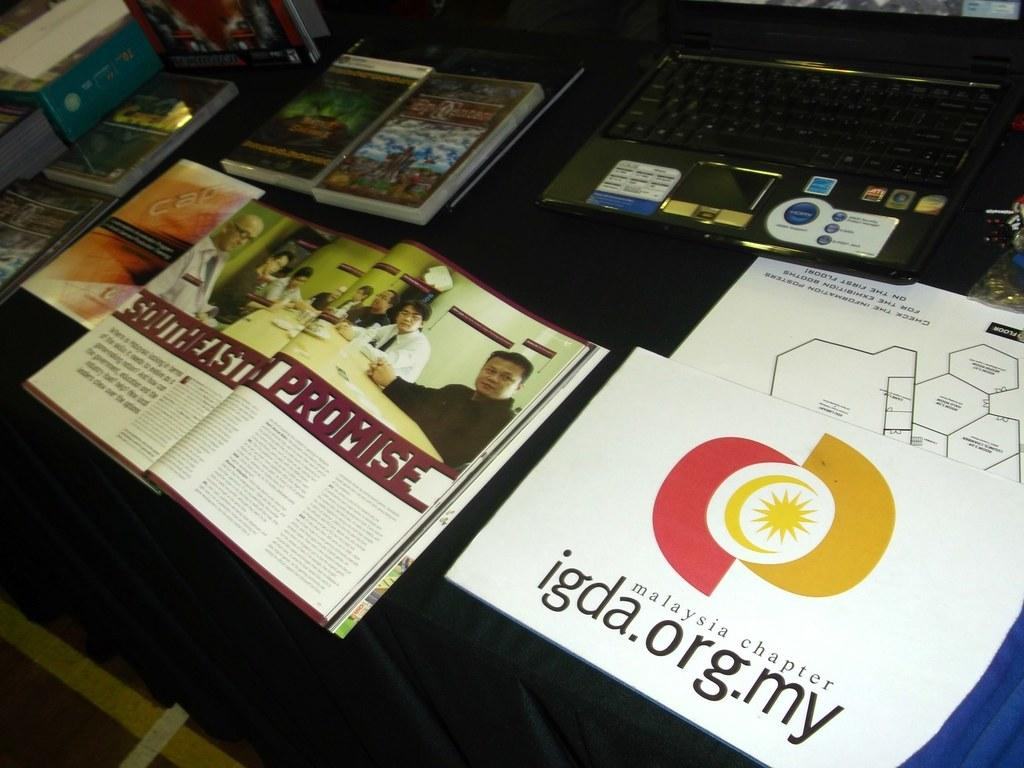<image>
Present a compact description of the photo's key features. A table has a laptop and books on it and one of them says Malaysia chapter. 